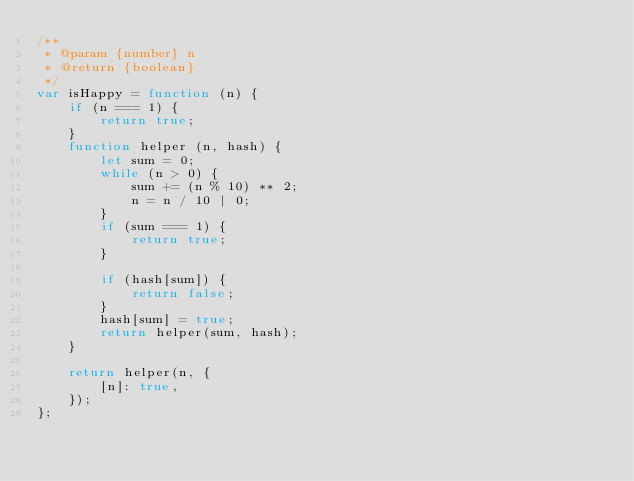<code> <loc_0><loc_0><loc_500><loc_500><_JavaScript_>/**
 * @param {number} n
 * @return {boolean}
 */
var isHappy = function (n) {
    if (n === 1) {
        return true;
    }
    function helper (n, hash) {
        let sum = 0;
        while (n > 0) {
            sum += (n % 10) ** 2;
            n = n / 10 | 0;
        }
        if (sum === 1) {
            return true;
        }

        if (hash[sum]) {
            return false;
        }
        hash[sum] = true;
        return helper(sum, hash);
    }

    return helper(n, {
        [n]: true,
    });
};
</code> 